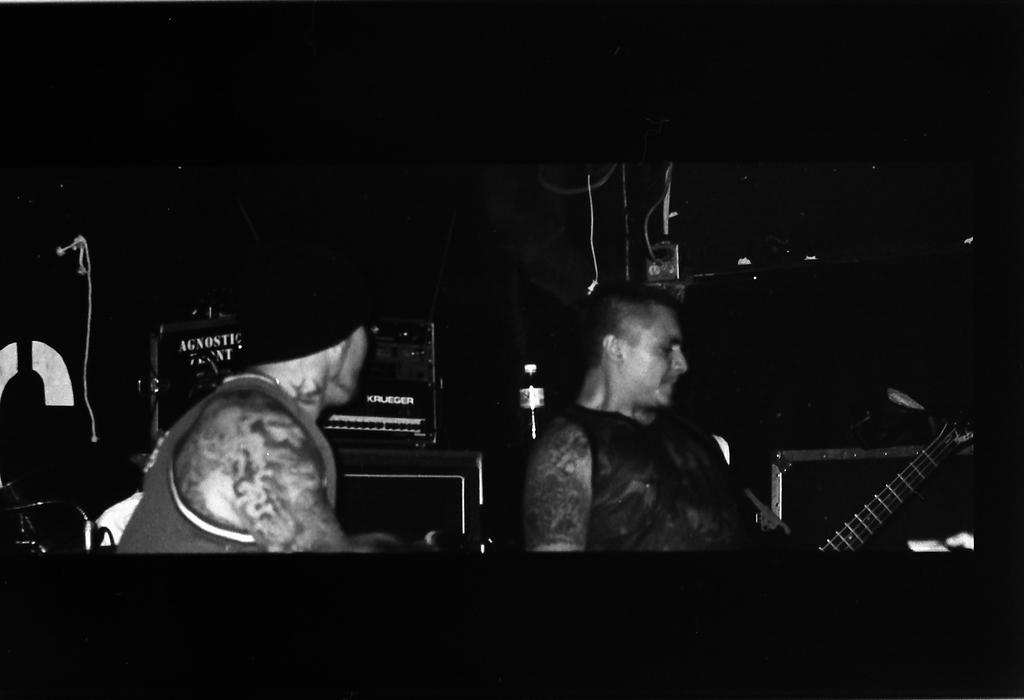How many people are in the image? There are two persons in the image. What object can be seen besides the people? There is a bottle in the image. What is one person holding? One person is holding a guitar. Who is the owner of the veil in the image? There is no veil present in the image. How many houses can be seen in the image? There are no houses visible in the image. 